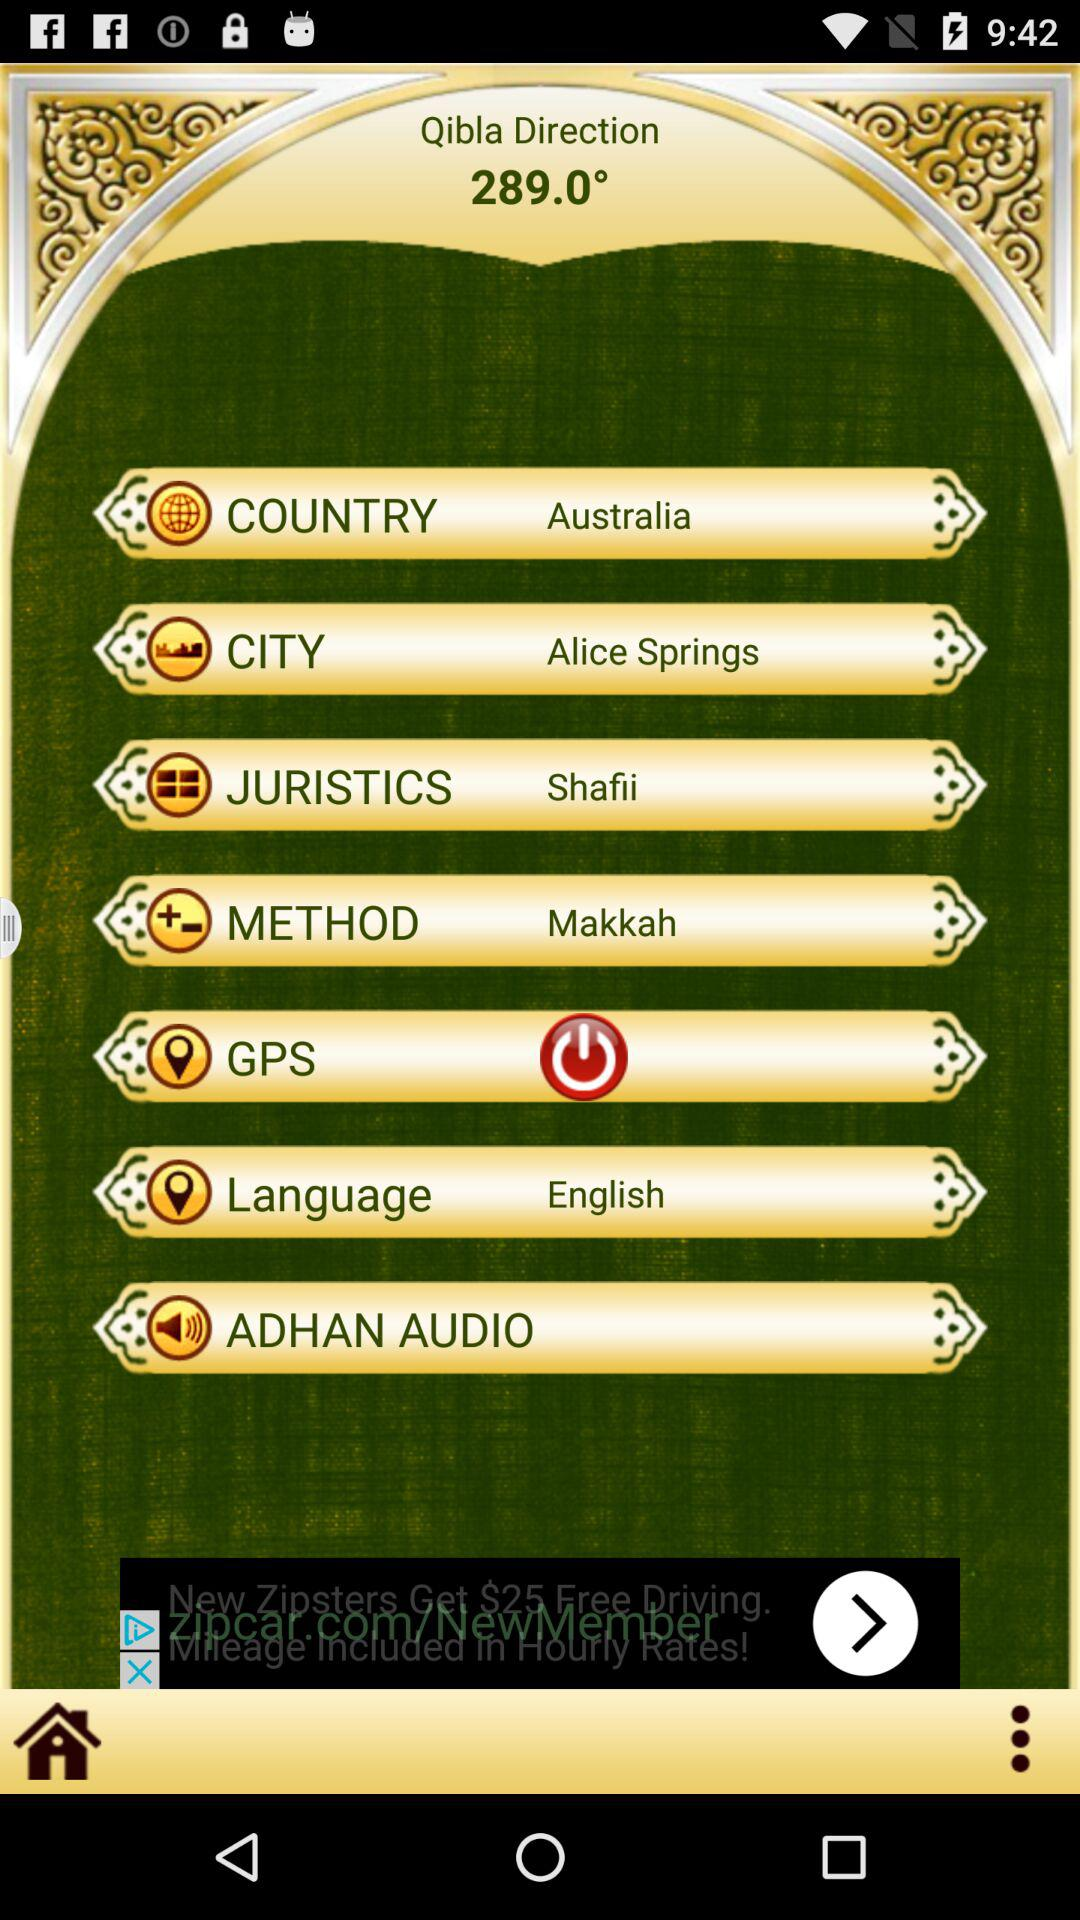Which is the selected city? The selected city is Alice Springs. 